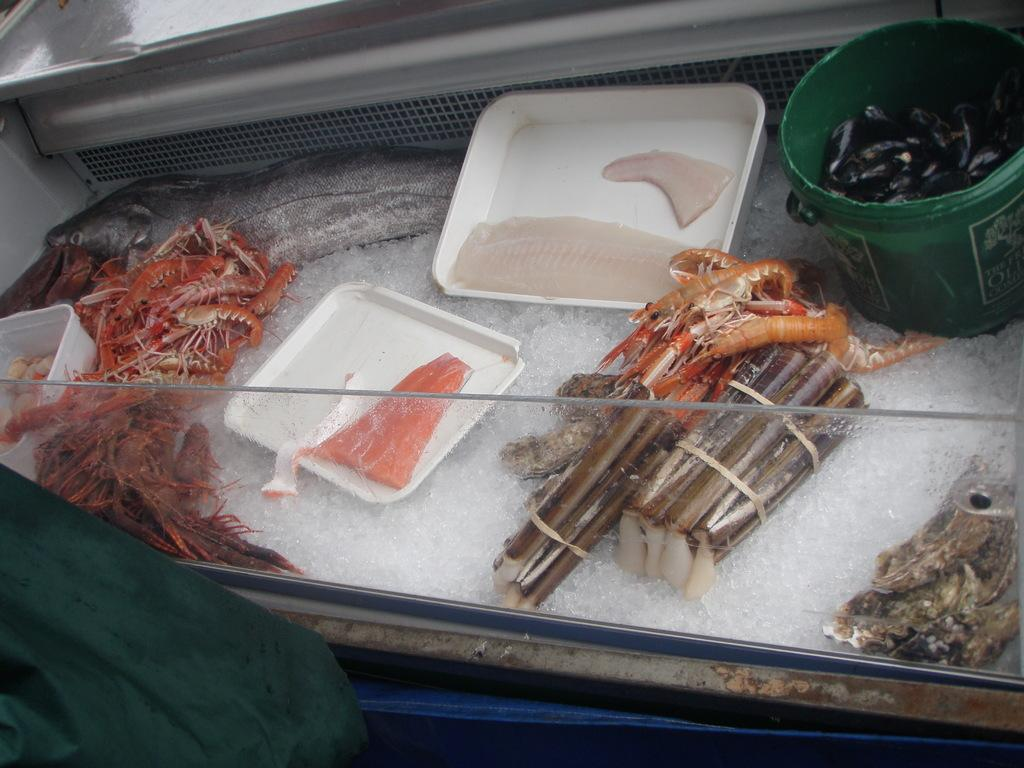What type of food is present in the image? There is seafood in the image. How is the seafood being stored or displayed? The seafood is kept on ice. What type of vehicle is used to drive the seafood in the image? There is no vehicle or driving involved in the image; it simply shows seafood being kept on ice. 